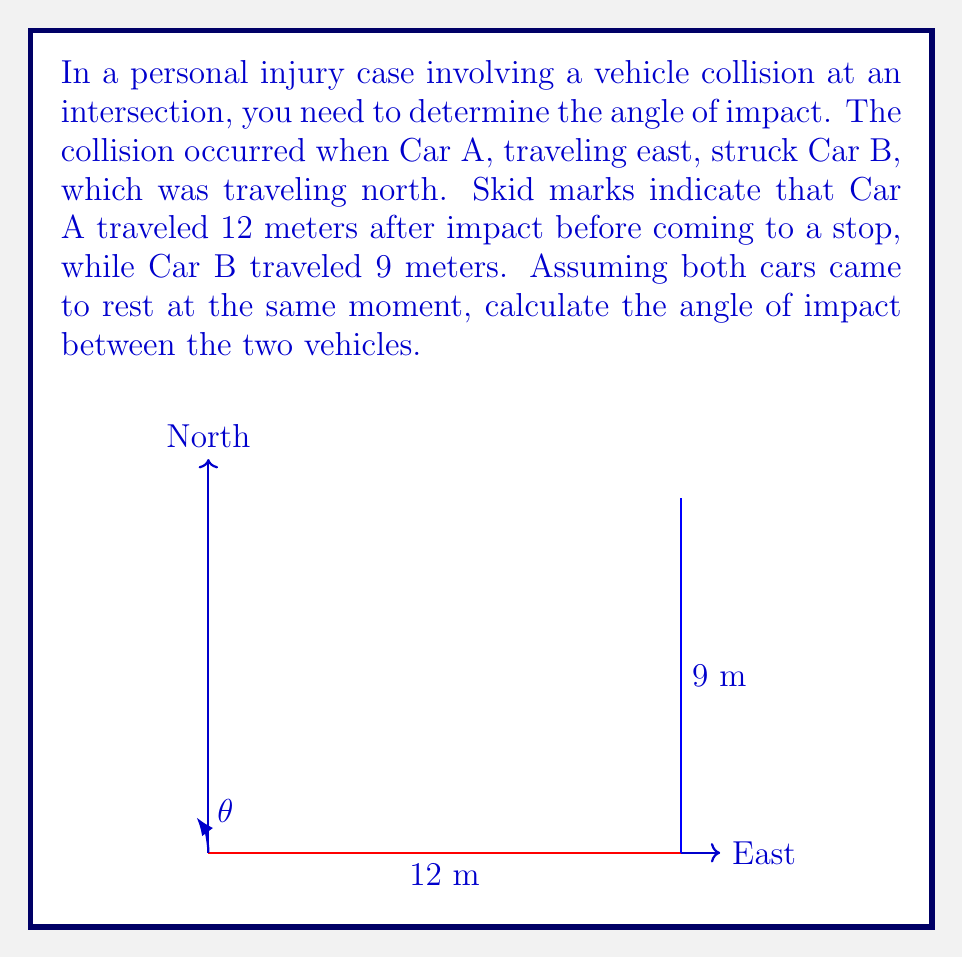What is the answer to this math problem? To solve this problem, we'll use trigonometry to determine the angle of impact. Let's approach this step-by-step:

1) The skid marks form a right-angled triangle, where:
   - The base (east direction) is 12 meters
   - The height (north direction) is 9 meters
   - The hypotenuse represents the actual path of the combined vehicles after impact

2) We can use the arctangent function to find the angle. In this case, we're looking for the angle between the base (east direction) and the hypotenuse.

3) The tangent of this angle is the ratio of the opposite side to the adjacent side:

   $$\tan(\theta) = \frac{\text{opposite}}{\text{adjacent}} = \frac{9}{12} = \frac{3}{4} = 0.75$$

4) To find the angle, we take the arctangent (inverse tangent) of this ratio:

   $$\theta = \arctan(0.75)$$

5) Using a calculator or trigonometric tables:

   $$\theta \approx 36.87^\circ$$

6) This angle represents the direction of travel after impact. The actual angle of impact would be the complement of this angle, i.e., 90° - 36.87°:

   $$\text{Angle of impact} = 90^\circ - 36.87^\circ \approx 53.13^\circ$$

Therefore, the angle of impact between the two vehicles was approximately 53.13°.
Answer: $53.13^\circ$ 